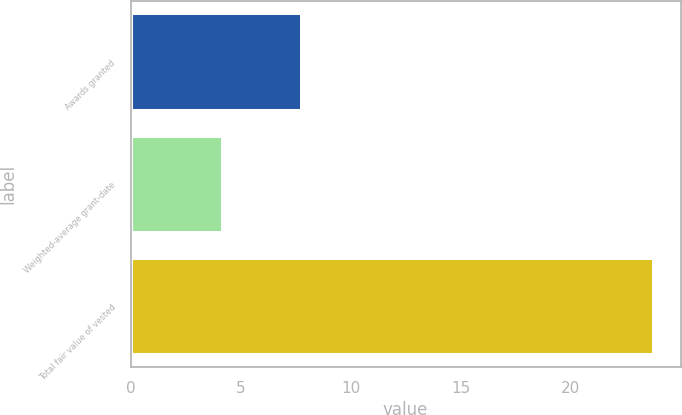Convert chart to OTSL. <chart><loc_0><loc_0><loc_500><loc_500><bar_chart><fcel>Awards granted<fcel>Weighted-average grant-date<fcel>Total fair value of vested<nl><fcel>7.8<fcel>4.21<fcel>23.8<nl></chart> 